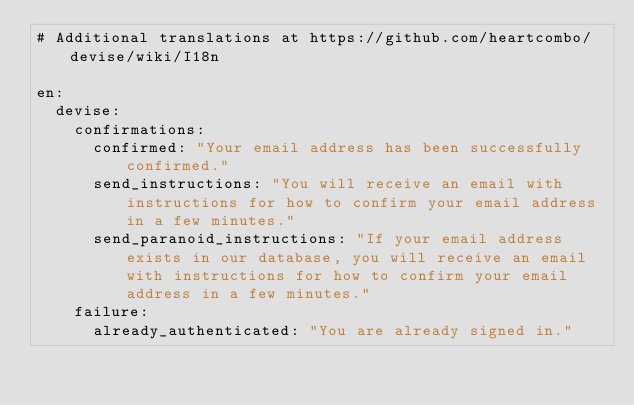Convert code to text. <code><loc_0><loc_0><loc_500><loc_500><_YAML_># Additional translations at https://github.com/heartcombo/devise/wiki/I18n

en:
  devise:
    confirmations:
      confirmed: "Your email address has been successfully confirmed."
      send_instructions: "You will receive an email with instructions for how to confirm your email address in a few minutes."
      send_paranoid_instructions: "If your email address exists in our database, you will receive an email with instructions for how to confirm your email address in a few minutes."
    failure:
      already_authenticated: "You are already signed in."</code> 